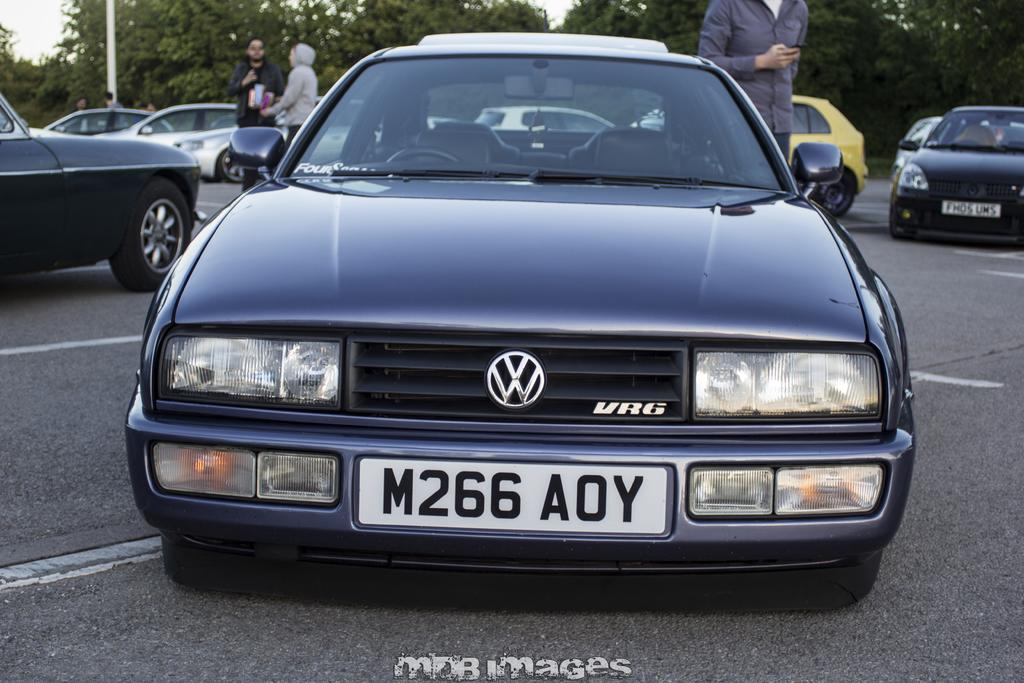What can be seen on the path in the image? There are vehicles parked on the path in the image. What else is visible in the image besides the parked vehicles? There are people standing in the image. What can be seen in the background of the image? There is a pole, trees, and the sky visible in the background of the image. Can you see a giraffe drinking soda from a thumb in the image? No, there is no giraffe, soda, or thumb present in the image. 